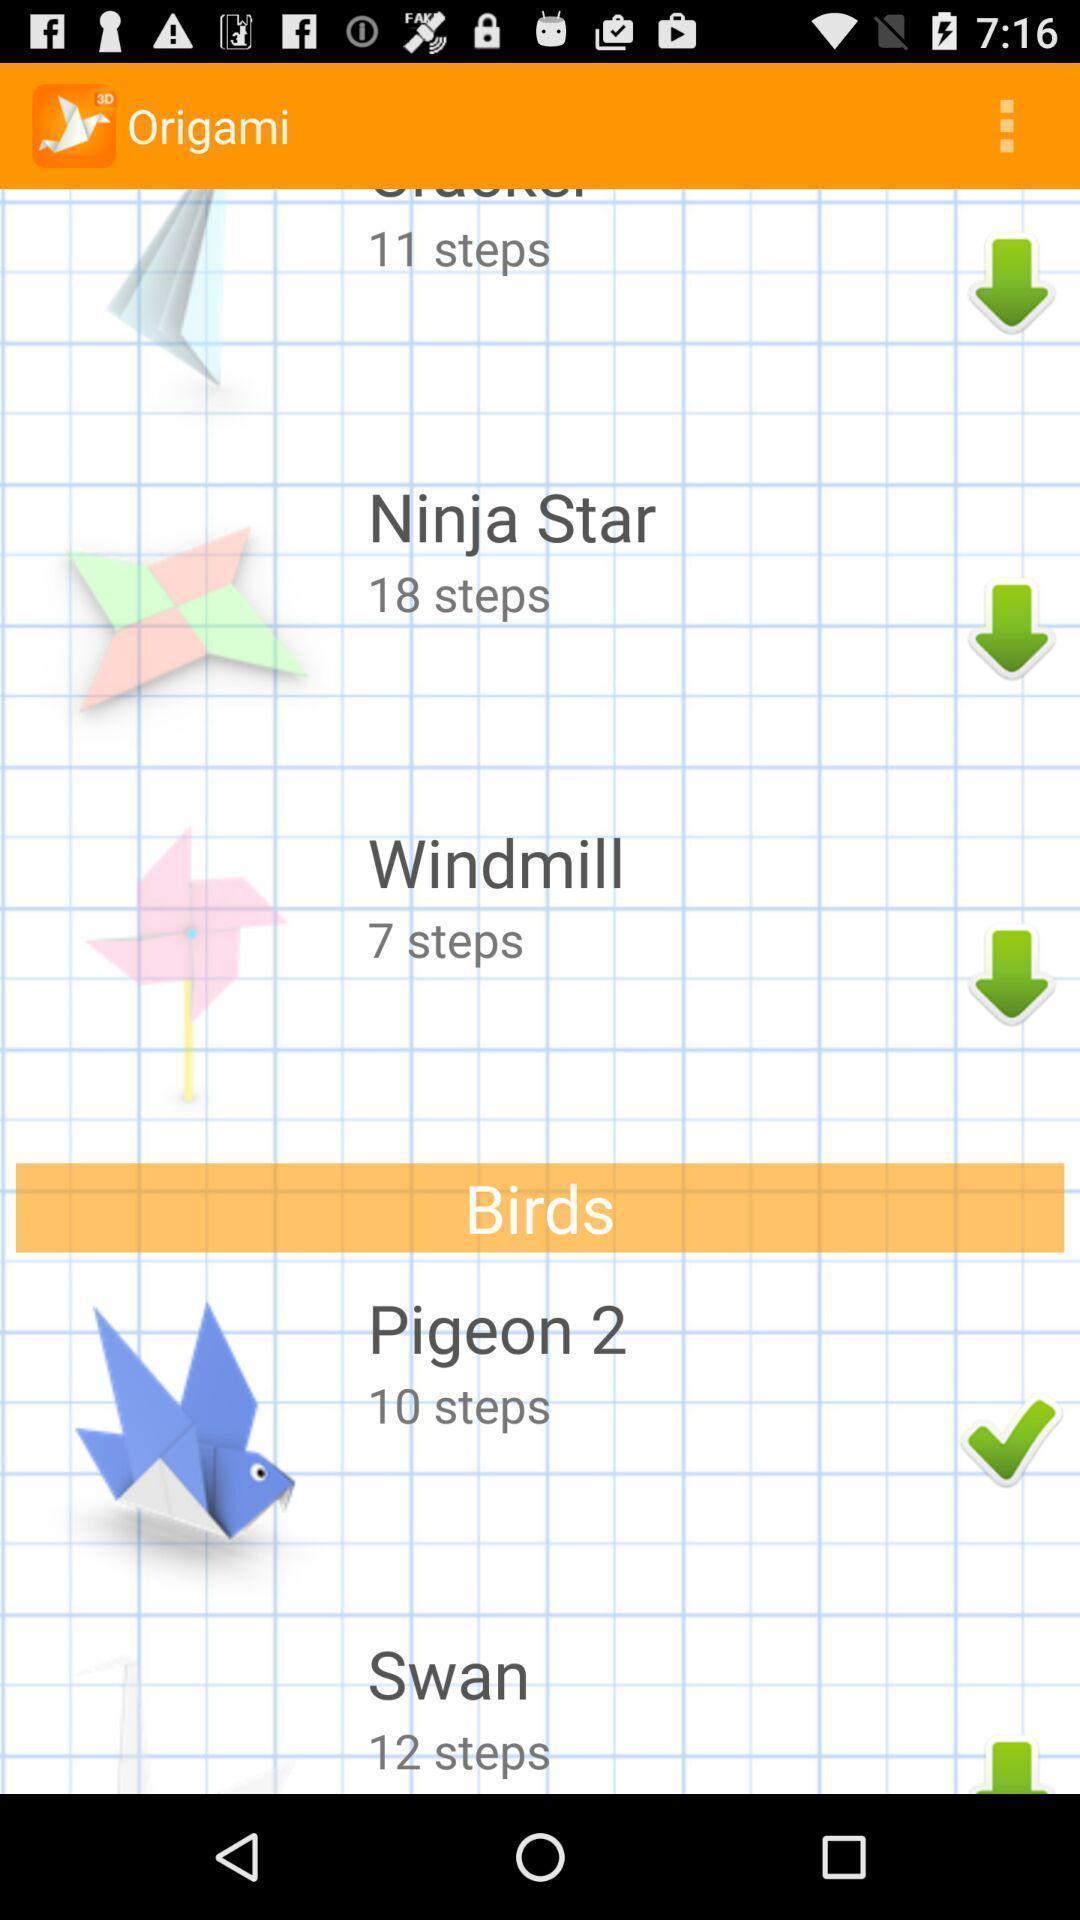Describe the key features of this screenshot. Screen displaying the screen page. 